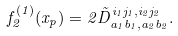Convert formula to latex. <formula><loc_0><loc_0><loc_500><loc_500>f _ { 2 } ^ { ( 1 ) } ( x _ { p } ) = 2 \tilde { D } _ { a _ { 1 } b _ { 1 } , a _ { 2 } b _ { 2 } } ^ { i _ { 1 } j _ { 1 } , i _ { 2 } j _ { 2 } } .</formula> 